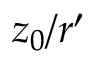Convert formula to latex. <formula><loc_0><loc_0><loc_500><loc_500>z _ { 0 } / r ^ { \prime }</formula> 